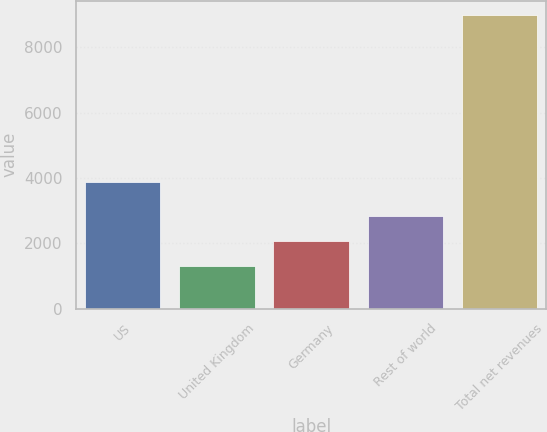Convert chart to OTSL. <chart><loc_0><loc_0><loc_500><loc_500><bar_chart><fcel>US<fcel>United Kingdom<fcel>Germany<fcel>Rest of world<fcel>Total net revenues<nl><fcel>3866<fcel>1315<fcel>2081.4<fcel>2847.8<fcel>8979<nl></chart> 